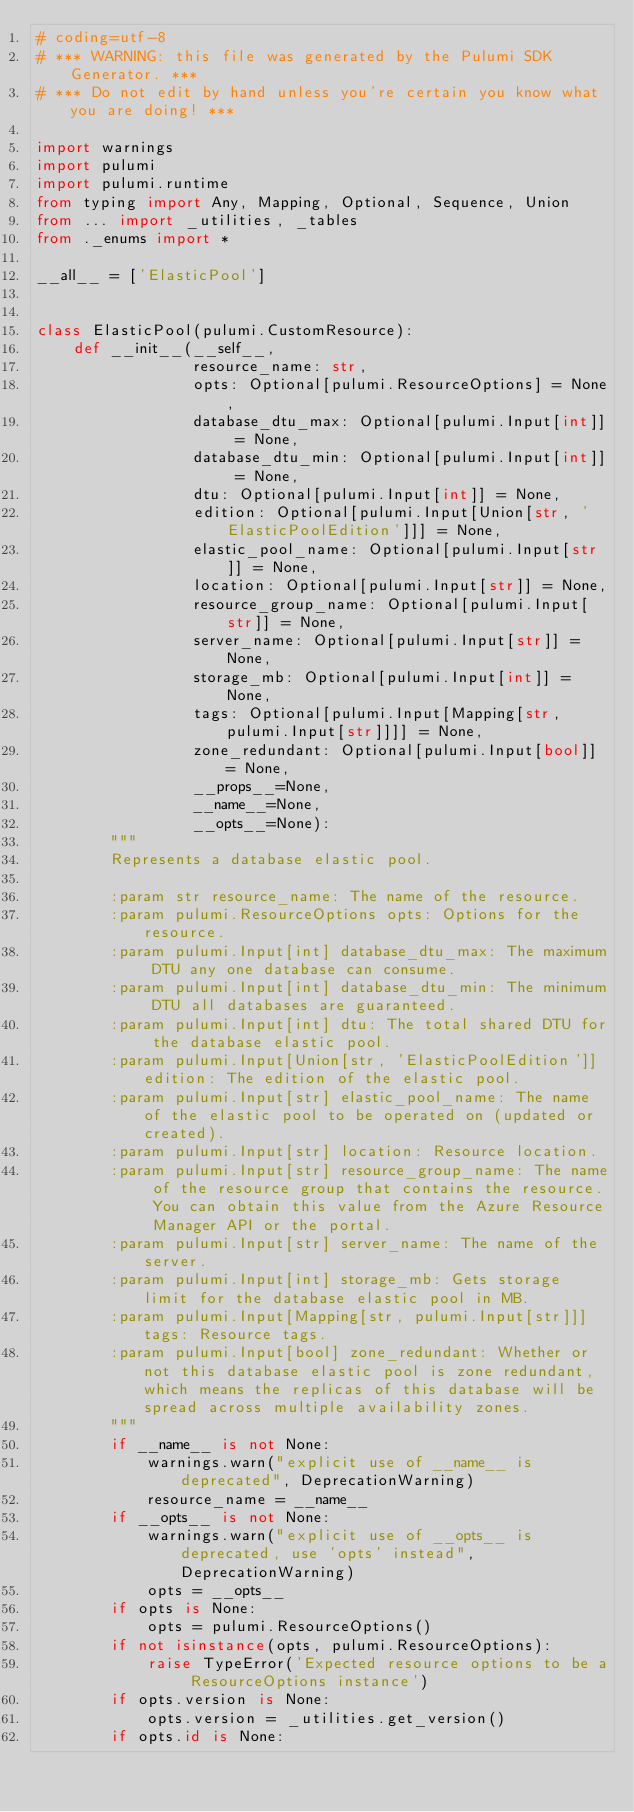Convert code to text. <code><loc_0><loc_0><loc_500><loc_500><_Python_># coding=utf-8
# *** WARNING: this file was generated by the Pulumi SDK Generator. ***
# *** Do not edit by hand unless you're certain you know what you are doing! ***

import warnings
import pulumi
import pulumi.runtime
from typing import Any, Mapping, Optional, Sequence, Union
from ... import _utilities, _tables
from ._enums import *

__all__ = ['ElasticPool']


class ElasticPool(pulumi.CustomResource):
    def __init__(__self__,
                 resource_name: str,
                 opts: Optional[pulumi.ResourceOptions] = None,
                 database_dtu_max: Optional[pulumi.Input[int]] = None,
                 database_dtu_min: Optional[pulumi.Input[int]] = None,
                 dtu: Optional[pulumi.Input[int]] = None,
                 edition: Optional[pulumi.Input[Union[str, 'ElasticPoolEdition']]] = None,
                 elastic_pool_name: Optional[pulumi.Input[str]] = None,
                 location: Optional[pulumi.Input[str]] = None,
                 resource_group_name: Optional[pulumi.Input[str]] = None,
                 server_name: Optional[pulumi.Input[str]] = None,
                 storage_mb: Optional[pulumi.Input[int]] = None,
                 tags: Optional[pulumi.Input[Mapping[str, pulumi.Input[str]]]] = None,
                 zone_redundant: Optional[pulumi.Input[bool]] = None,
                 __props__=None,
                 __name__=None,
                 __opts__=None):
        """
        Represents a database elastic pool.

        :param str resource_name: The name of the resource.
        :param pulumi.ResourceOptions opts: Options for the resource.
        :param pulumi.Input[int] database_dtu_max: The maximum DTU any one database can consume.
        :param pulumi.Input[int] database_dtu_min: The minimum DTU all databases are guaranteed.
        :param pulumi.Input[int] dtu: The total shared DTU for the database elastic pool.
        :param pulumi.Input[Union[str, 'ElasticPoolEdition']] edition: The edition of the elastic pool.
        :param pulumi.Input[str] elastic_pool_name: The name of the elastic pool to be operated on (updated or created).
        :param pulumi.Input[str] location: Resource location.
        :param pulumi.Input[str] resource_group_name: The name of the resource group that contains the resource. You can obtain this value from the Azure Resource Manager API or the portal.
        :param pulumi.Input[str] server_name: The name of the server.
        :param pulumi.Input[int] storage_mb: Gets storage limit for the database elastic pool in MB.
        :param pulumi.Input[Mapping[str, pulumi.Input[str]]] tags: Resource tags.
        :param pulumi.Input[bool] zone_redundant: Whether or not this database elastic pool is zone redundant, which means the replicas of this database will be spread across multiple availability zones.
        """
        if __name__ is not None:
            warnings.warn("explicit use of __name__ is deprecated", DeprecationWarning)
            resource_name = __name__
        if __opts__ is not None:
            warnings.warn("explicit use of __opts__ is deprecated, use 'opts' instead", DeprecationWarning)
            opts = __opts__
        if opts is None:
            opts = pulumi.ResourceOptions()
        if not isinstance(opts, pulumi.ResourceOptions):
            raise TypeError('Expected resource options to be a ResourceOptions instance')
        if opts.version is None:
            opts.version = _utilities.get_version()
        if opts.id is None:</code> 